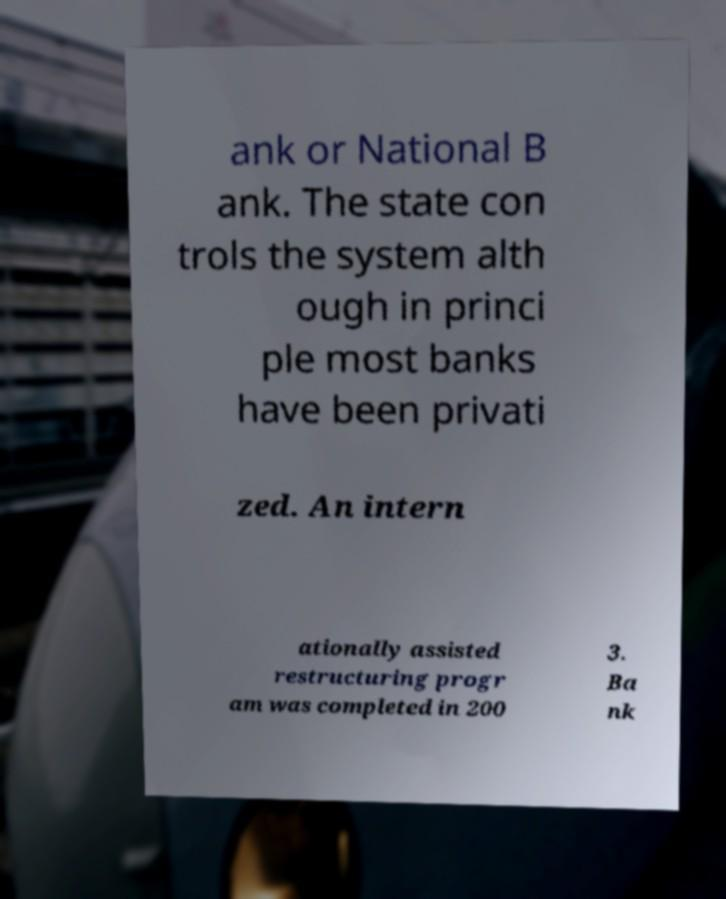What messages or text are displayed in this image? I need them in a readable, typed format. ank or National B ank. The state con trols the system alth ough in princi ple most banks have been privati zed. An intern ationally assisted restructuring progr am was completed in 200 3. Ba nk 